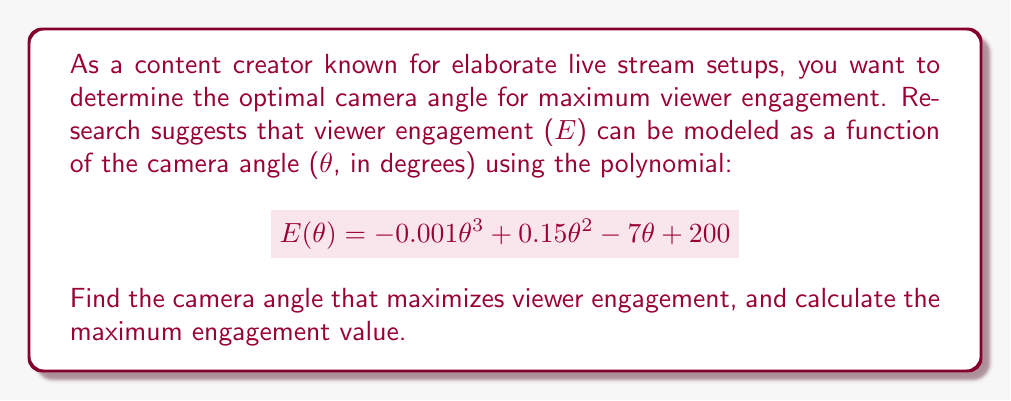Solve this math problem. To find the optimal camera angle for maximum viewer engagement, we need to follow these steps:

1) First, we need to find the derivative of the engagement function $E(\theta)$:
   $$E'(\theta) = -0.003\theta^2 + 0.3\theta - 7$$

2) To find the maximum, we set the derivative equal to zero and solve for $\theta$:
   $$-0.003\theta^2 + 0.3\theta - 7 = 0$$

3) This is a quadratic equation. We can solve it using the quadratic formula:
   $$\theta = \frac{-b \pm \sqrt{b^2 - 4ac}}{2a}$$
   where $a = -0.003$, $b = 0.3$, and $c = -7$

4) Plugging in these values:
   $$\theta = \frac{-0.3 \pm \sqrt{0.3^2 - 4(-0.003)(-7)}}{2(-0.003)}$$
   $$= \frac{-0.3 \pm \sqrt{0.09 + 0.084}}{-0.006}$$
   $$= \frac{-0.3 \pm \sqrt{0.174}}{-0.006}$$
   $$= \frac{-0.3 \pm 0.417}{-0.006}$$

5) This gives us two solutions:
   $$\theta_1 = \frac{-0.3 + 0.417}{-0.006} \approx 19.5$$
   $$\theta_2 = \frac{-0.3 - 0.417}{-0.006} \approx 119.5$$

6) To determine which of these is the maximum (rather than the minimum), we can check the second derivative:
   $$E''(\theta) = -0.006\theta + 0.3$$

7) At $\theta = 19.5$, $E''(19.5) = -0.006(19.5) + 0.3 = 0.183 > 0$, indicating a local minimum.
   At $\theta = 119.5$, $E''(119.5) = -0.006(119.5) + 0.3 = -0.417 < 0$, indicating a local maximum.

8) Therefore, the optimal angle is approximately 119.5 degrees.

9) To find the maximum engagement value, we plug this back into our original function:
   $$E(119.5) = -0.001(119.5)^3 + 0.15(119.5)^2 - 7(119.5) + 200$$
   $$\approx 283.14$$
Answer: The optimal camera angle is approximately 119.5 degrees, which yields a maximum viewer engagement of approximately 283.14. 